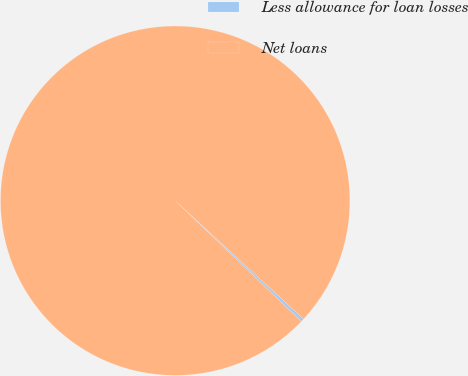<chart> <loc_0><loc_0><loc_500><loc_500><pie_chart><fcel>Less allowance for loan losses<fcel>Net loans<nl><fcel>0.28%<fcel>99.72%<nl></chart> 